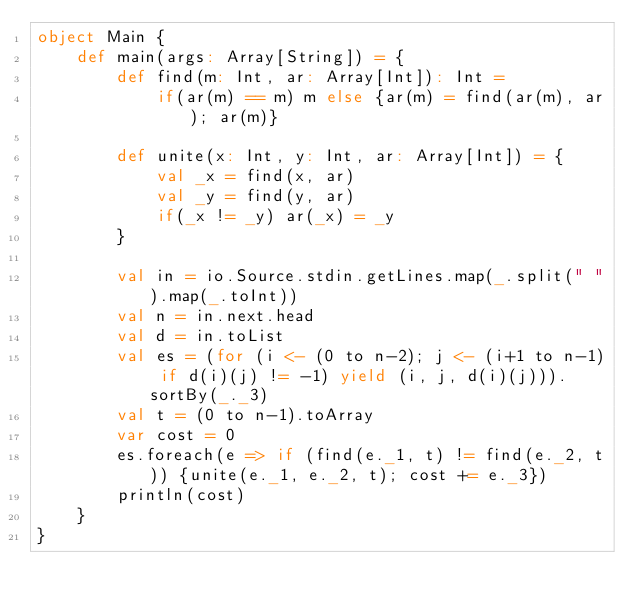<code> <loc_0><loc_0><loc_500><loc_500><_Scala_>object Main {
    def main(args: Array[String]) = {
        def find(m: Int, ar: Array[Int]): Int = 
            if(ar(m) == m) m else {ar(m) = find(ar(m), ar); ar(m)}
     
        def unite(x: Int, y: Int, ar: Array[Int]) = {
            val _x = find(x, ar)
            val _y = find(y, ar)
            if(_x != _y) ar(_x) = _y
        }
     
        val in = io.Source.stdin.getLines.map(_.split(" ").map(_.toInt))
        val n = in.next.head
        val d = in.toList
        val es = (for (i <- (0 to n-2); j <- (i+1 to n-1) if d(i)(j) != -1) yield (i, j, d(i)(j))).sortBy(_._3)
        val t = (0 to n-1).toArray
        var cost = 0
        es.foreach(e => if (find(e._1, t) != find(e._2, t)) {unite(e._1, e._2, t); cost += e._3})
        println(cost)
    }
}</code> 